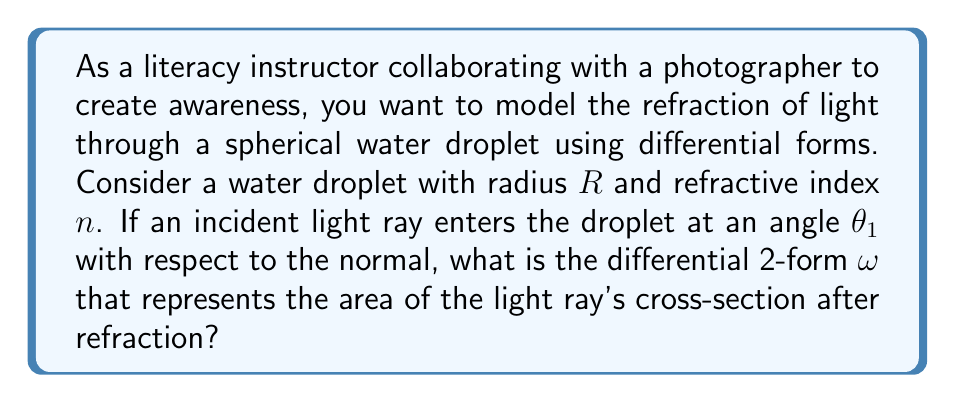Could you help me with this problem? To solve this problem, we'll follow these steps:

1) First, recall Snell's law of refraction:
   $$n_1 \sin(\theta_1) = n_2 \sin(\theta_2)$$
   where $n_1 = 1$ (air) and $n_2 = n$ (water)

2) Using Snell's law, we can express $\theta_2$ in terms of $\theta_1$:
   $$\sin(\theta_2) = \frac{\sin(\theta_1)}{n}$$

3) The area of the light ray's cross-section is proportional to the square of its radius. Let's call the initial radius $r_1$ and the refracted radius $r_2$. The ratio of these radii is inversely proportional to the ratio of the sines of the angles:

   $$\frac{r_2}{r_1} = \frac{\sin(\theta_1)}{\sin(\theta_2)}$$

4) Substituting the result from step 2:

   $$\frac{r_2}{r_1} = \frac{\sin(\theta_1)}{\frac{\sin(\theta_1)}{n}} = n$$

5) The area of the cross-section is proportional to $r^2$, so the ratio of areas is:

   $$\frac{A_2}{A_1} = \left(\frac{r_2}{r_1}\right)^2 = n^2$$

6) In differential geometry, we can represent this area as a 2-form $\omega$. The initial 2-form $\omega_1$ transforms to $\omega_2$ after refraction:

   $$\omega_2 = n^2 \omega_1$$

7) We can express $\omega_1$ in polar coordinates $(r, \phi)$ as:

   $$\omega_1 = r dr \wedge d\phi$$

8) Therefore, the final 2-form $\omega_2$ is:

   $$\omega_2 = n^2 r dr \wedge d\phi$$

This 2-form $\omega_2$ represents the area of the light ray's cross-section after refraction through the water droplet.
Answer: $\omega = n^2 r dr \wedge d\phi$ 